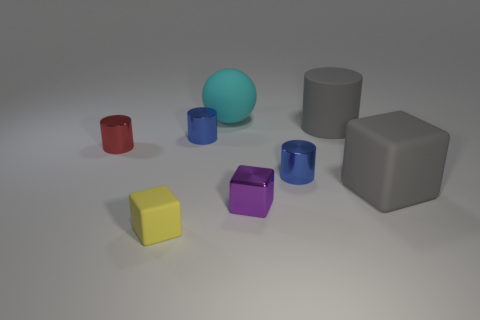What shape is the yellow object that is in front of the gray thing behind the big gray cube?
Provide a succinct answer. Cube. What material is the object that is the same color as the large rubber block?
Offer a very short reply. Rubber. What color is the block that is made of the same material as the red cylinder?
Provide a short and direct response. Purple. Is there anything else that is the same size as the cyan thing?
Ensure brevity in your answer.  Yes. Is the color of the block that is to the left of the large sphere the same as the large block in front of the cyan matte object?
Your response must be concise. No. Are there more gray matte cubes that are to the left of the sphere than small blue shiny cylinders that are on the right side of the tiny purple cube?
Provide a succinct answer. No. The big object that is the same shape as the small yellow thing is what color?
Give a very brief answer. Gray. Is there any other thing that has the same shape as the cyan rubber thing?
Your answer should be compact. No. There is a tiny red metal thing; is it the same shape as the large gray rubber object that is on the left side of the gray rubber cube?
Your response must be concise. Yes. What number of other objects are there of the same material as the purple object?
Your response must be concise. 3. 